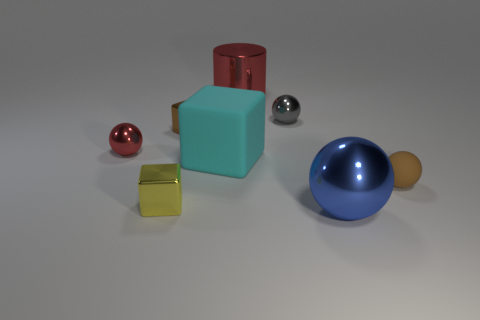Subtract all brown blocks. How many blocks are left? 2 Add 1 tiny gray things. How many objects exist? 9 Subtract all yellow cubes. How many cubes are left? 2 Subtract 2 cubes. How many cubes are left? 1 Add 2 tiny gray balls. How many tiny gray balls are left? 3 Add 4 small red metallic objects. How many small red metallic objects exist? 5 Subtract 1 red spheres. How many objects are left? 7 Subtract all cylinders. How many objects are left? 7 Subtract all gray balls. Subtract all purple cylinders. How many balls are left? 3 Subtract all purple spheres. How many yellow cubes are left? 1 